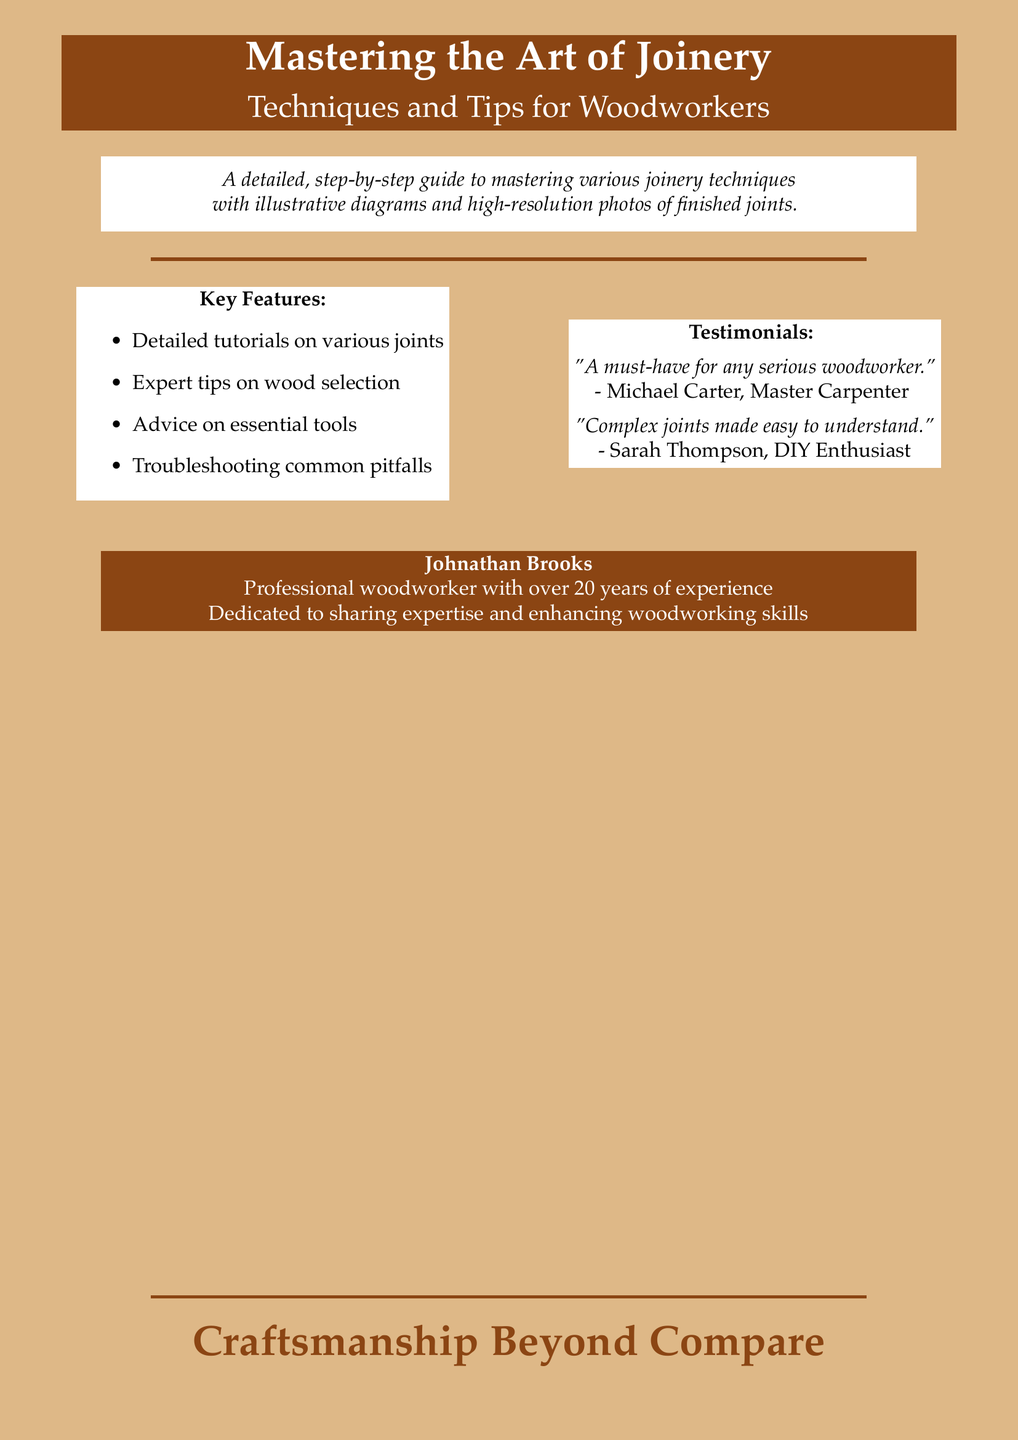What is the title of the book? The title is prominently displayed at the top of the cover.
Answer: Mastering the Art of Joinery Who is the author of the book? The author is mentioned towards the bottom of the cover.
Answer: Johnathan Brooks How many years of experience does the author have? This information is provided in the author's description section.
Answer: Over 20 years What is one key feature highlighted on the cover? The features are listed in a bullet format on one side of the cover.
Answer: Detailed tutorials on various joints Which testimonial is given by a master carpenter? Testimonials are provided on one side of the cover, including names for context.
Answer: "A must-have for any serious woodworker." What color is the background of the cover? The background color is described at the beginning of the document setup.
Answer: Lightwood What phrase highlights the quality of craftsmanship? This phrase is used at the very bottom of the cover.
Answer: Craftsmanship Beyond Compare What type of diagrams are mentioned in the book description? The book description refers specifically to visual aids within the content.
Answer: Illustrative diagrams 